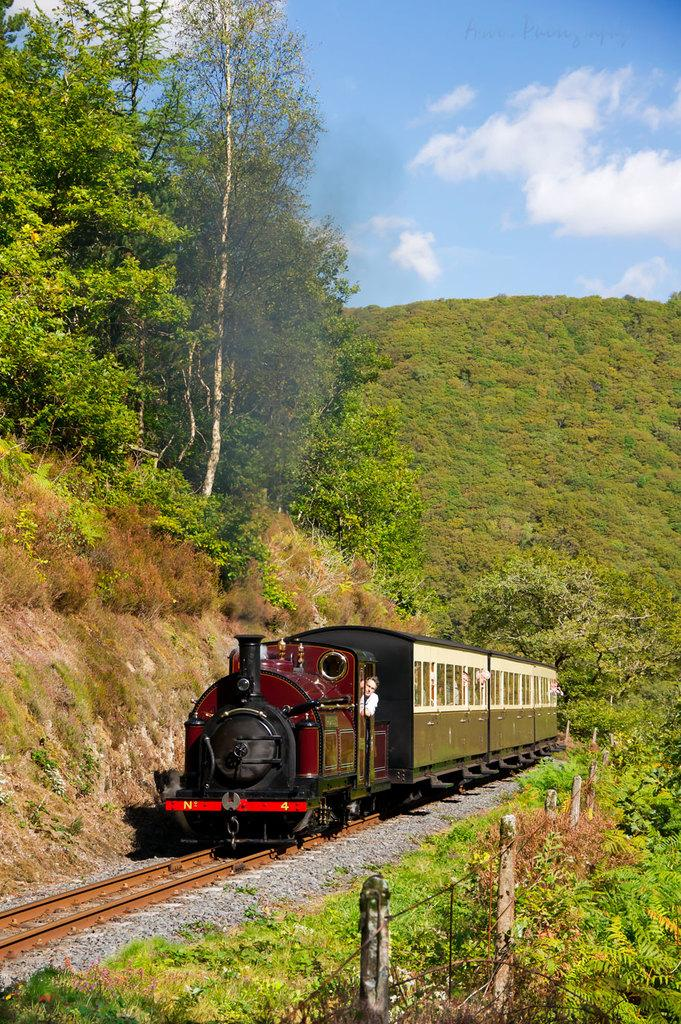What is the main subject of the image? There is a train in the image. What is the color of the train? The train is maroon in color. Where is the train located in the image? The train is on a track. What can be seen in the background of the image? There are trees and the sky visible in the background of the image. What is the color of the trees? The trees are green in color. What is the color of the sky? The sky is blue and white in color. How many pairs of shoes can be seen hanging from the trees in the image? There are no shoes visible in the image; only a train, trees, and the sky can be seen. Can you spot a jellyfish in the image? There are no jellyfish present in the image. 